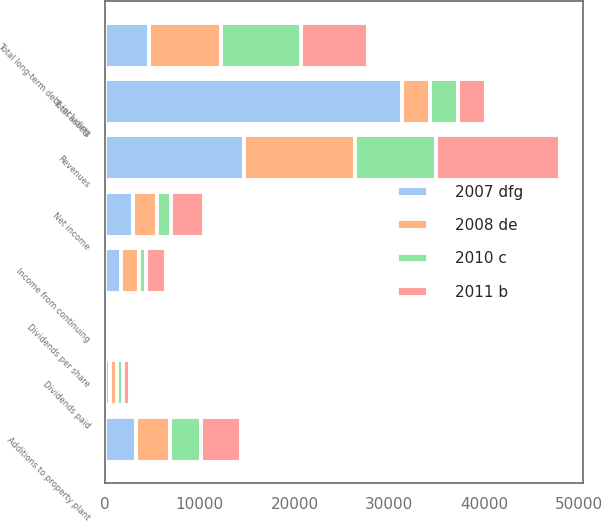Convert chart. <chart><loc_0><loc_0><loc_500><loc_500><stacked_bar_chart><ecel><fcel>Revenues<fcel>Income from continuing<fcel>Net income<fcel>Additions to property plant<fcel>Dividends paid<fcel>Dividends per share<fcel>Total assets<fcel>Total long-term debt including<nl><fcel>2007 dfg<fcel>14663<fcel>1707<fcel>2946<fcel>3295<fcel>567<fcel>0.8<fcel>31371<fcel>4674<nl><fcel>2008 de<fcel>11690<fcel>1882<fcel>2568<fcel>3536<fcel>704<fcel>0.99<fcel>2946<fcel>7601<nl><fcel>2010 c<fcel>8524<fcel>716<fcel>1463<fcel>3349<fcel>679<fcel>0.96<fcel>2946<fcel>8436<nl><fcel>2011 b<fcel>13162<fcel>2192<fcel>3528<fcel>4202<fcel>681<fcel>0.96<fcel>2946<fcel>7087<nl></chart> 